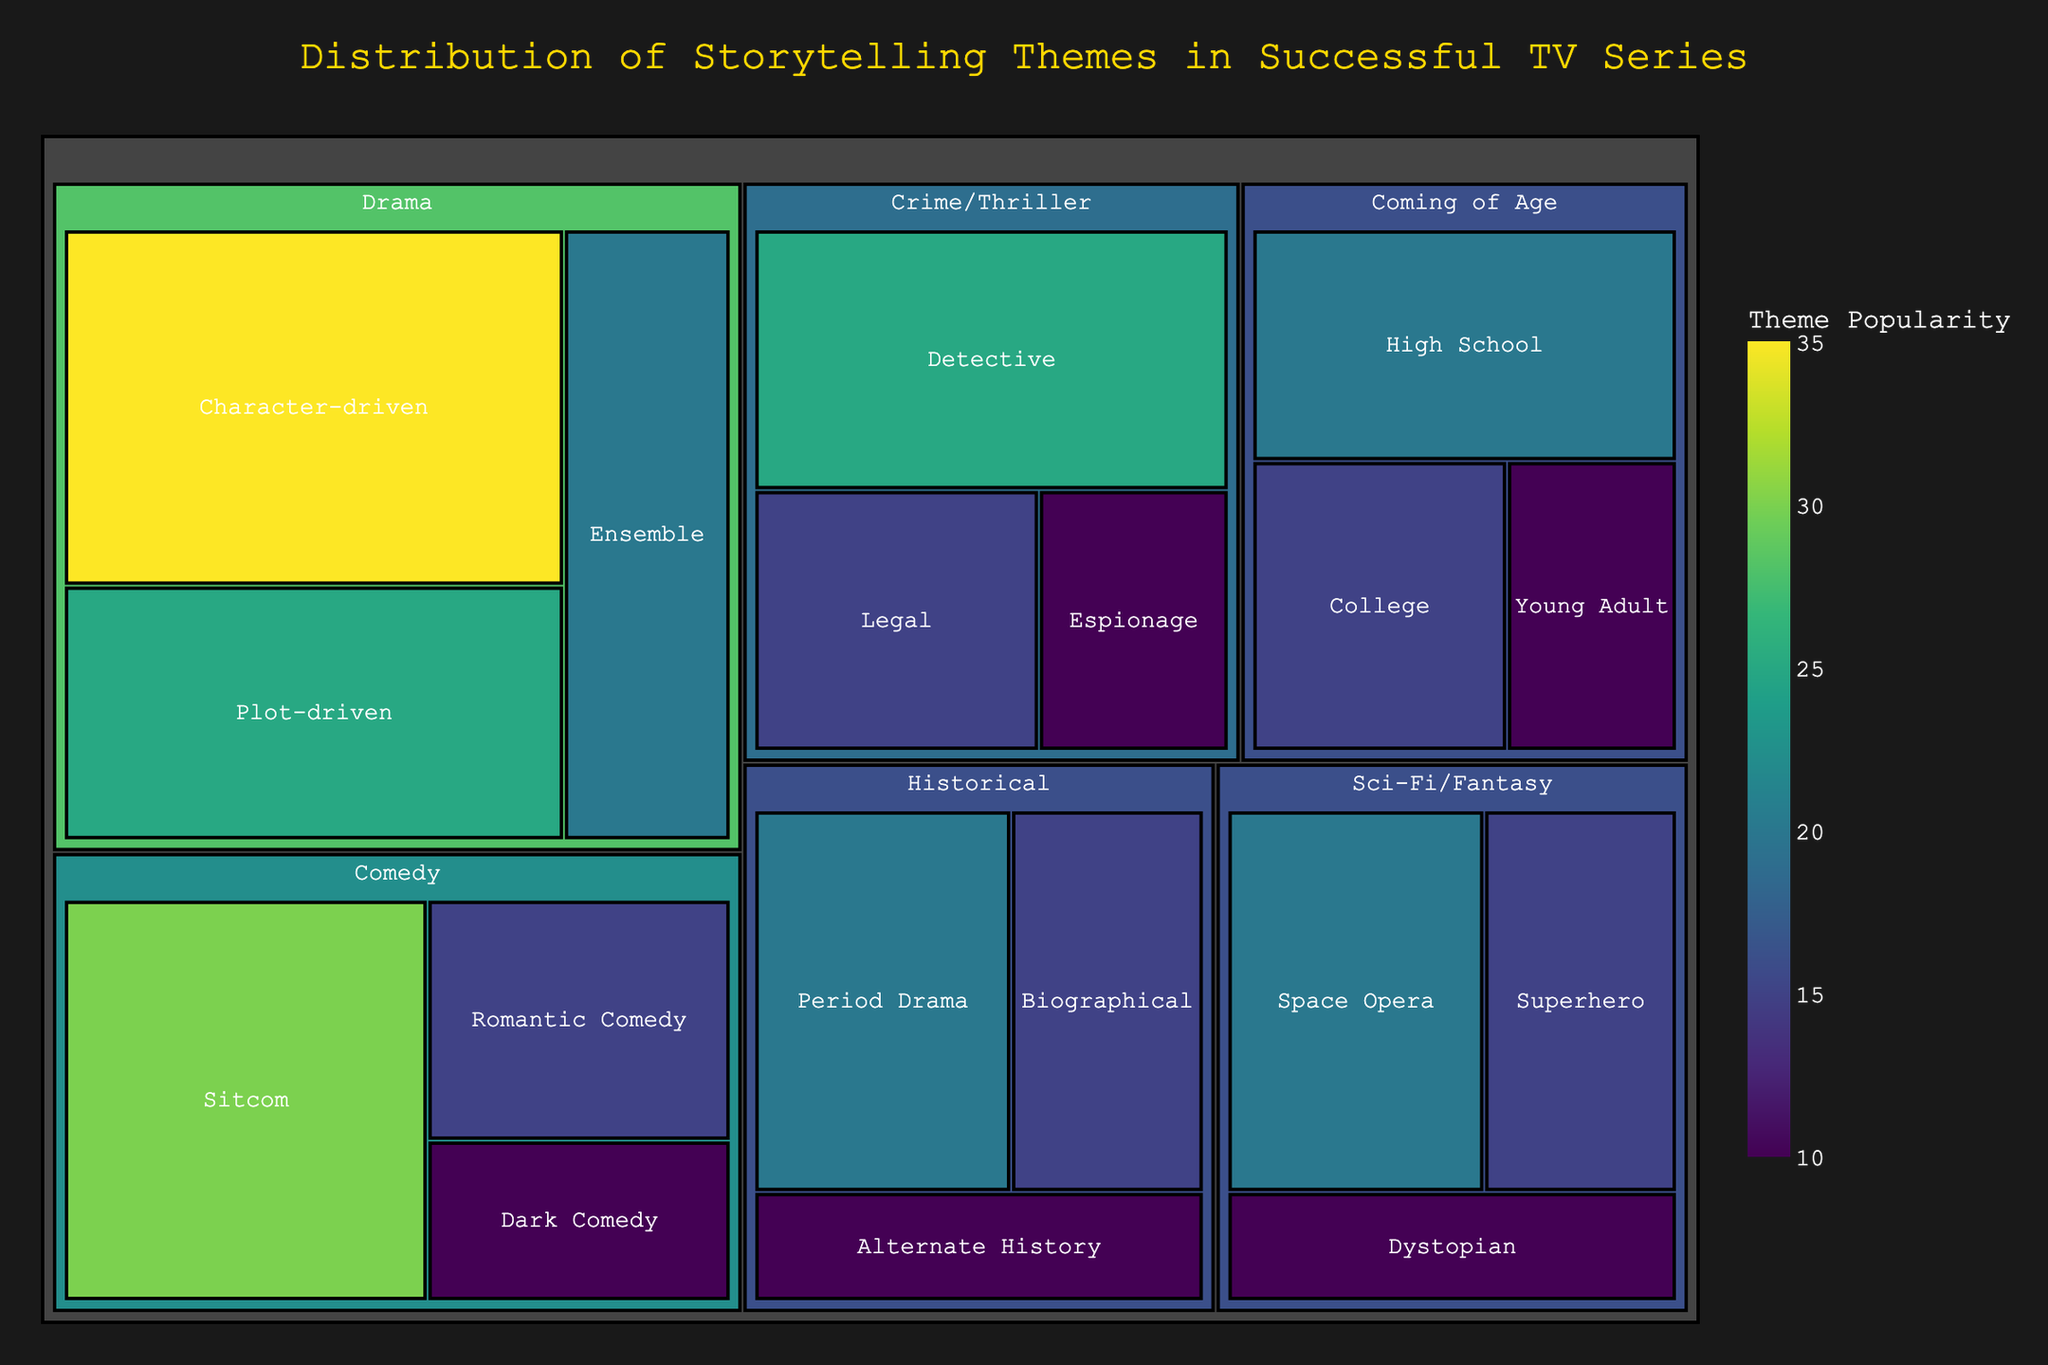How many subcategories does the Drama category have? To find the number of subcategories in the Drama category, one must look under the Drama branch and count the subcategories listed. There are three subcategories: Character-driven, Plot-driven, and Ensemble.
Answer: 3 Which subcategory has the highest value in the Comedy category? The Comedy category consists of Sitcom, Romantic Comedy, and Dark Comedy. Among these, Sitcom has the highest value, which is 30.
Answer: Sitcom What's the total value of all subcategories in the Crime/Thriller category? To find the total value, sum up the values of Detective (25), Legal (15), and Espionage (10). The total value is 25 + 15 + 10 = 50.
Answer: 50 What's the difference in value between Space Opera and Superhero in the Sci-Fi/Fantasy category? In the Sci-Fi/Fantasy category, Space Opera has a value of 20, and Superhero has a value of 15. The difference in value is 20 - 15 = 5.
Answer: 5 Which subcategory in the Historical category has the lowest value? The subcategories in the Historical category are Period Drama, Biographical, and Alternate History. Among these, Alternate History has the lowest value, which is 10.
Answer: Alternate History How does the popularity of High School themed series in the Coming of Age category compare to the popularity of Legal themed series in the Crime/Thriller category? High School in the Coming of Age category has a value of 20, while Legal in the Crime/Thriller category has a value of 15. High School themed series are more popular by a difference of 5.
Answer: High School is more popular What's the collective value of subcategories in both the Comedy and Historical categories? The Comedy category has subcategories with values Sitcom (30), Romantic Comedy (15), and Dark Comedy (10). The Historical category has subcategories with values Period Drama (20), Biographical (15), and Alternate History (10). The collective value is 30 + 15 + 10 + 20 + 15 + 10 = 100.
Answer: 100 Which category has the highest total value across all its subcategories? Sum up the values for each category:
   Drama: 35 + 25 + 20 = 80
   Comedy: 30 + 15 + 10 = 55
   Sci-Fi/Fantasy: 20 + 15 + 10 = 45
   Crime/Thriller: 25 + 15 + 10 = 50
   Coming of Age: 20 + 15 + 10 = 45
   Historical: 20 + 15 + 10 = 45
The Drama category has the highest total value of 80.
Answer: Drama What is the average value of subcategories in the Sci-Fi/Fantasy category? The Sci-Fi/Fantasy category includes Space Opera (20), Superhero (15), and Dystopian (10). The average value is calculated as (20 + 15 + 10) / 3 = 45 / 3 = 15.
Answer: 15 